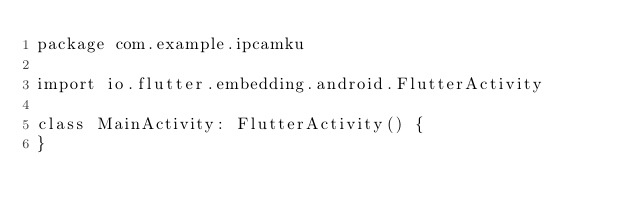<code> <loc_0><loc_0><loc_500><loc_500><_Kotlin_>package com.example.ipcamku

import io.flutter.embedding.android.FlutterActivity

class MainActivity: FlutterActivity() {
}
</code> 